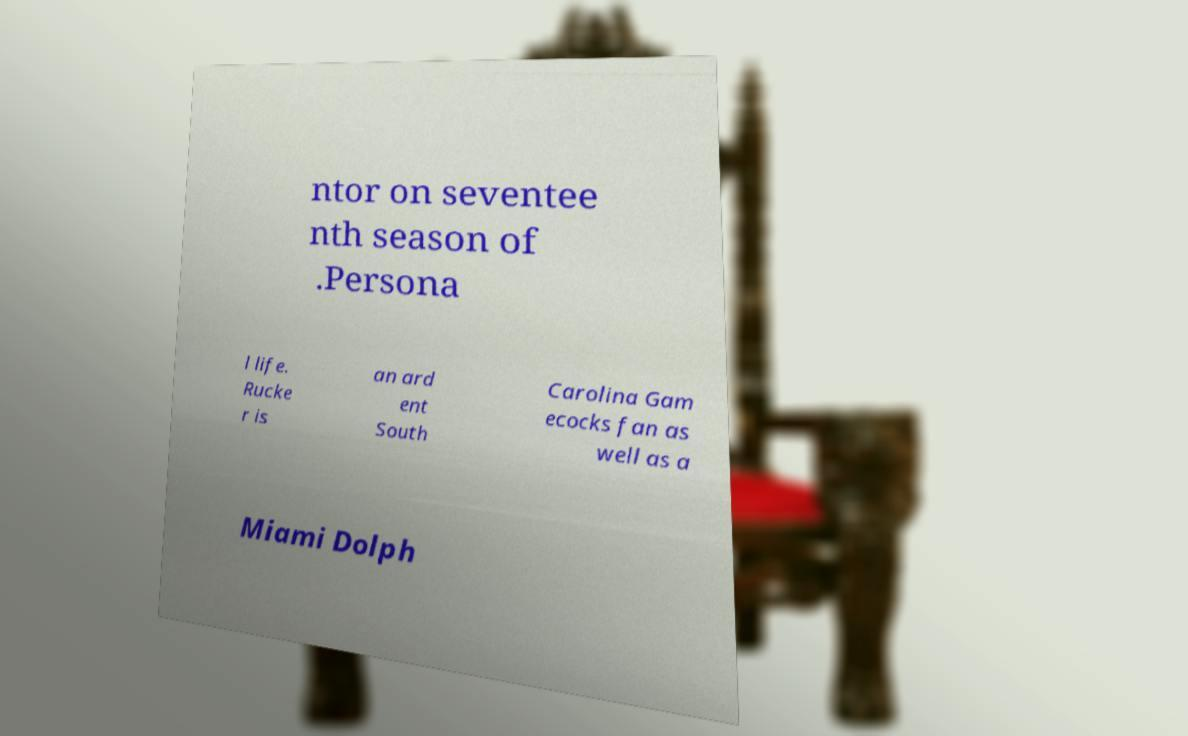Could you assist in decoding the text presented in this image and type it out clearly? ntor on seventee nth season of .Persona l life. Rucke r is an ard ent South Carolina Gam ecocks fan as well as a Miami Dolph 